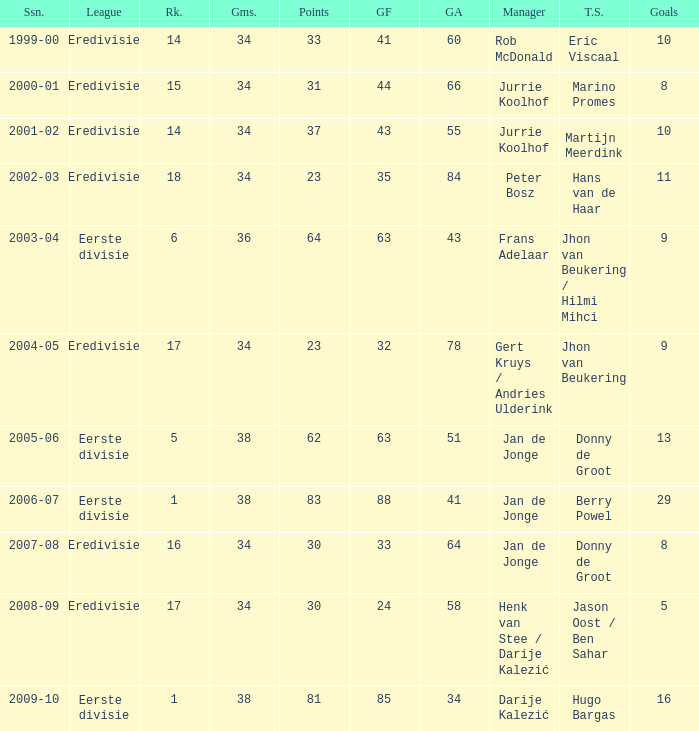What is the rank of manager Rob Mcdonald? 1.0. 